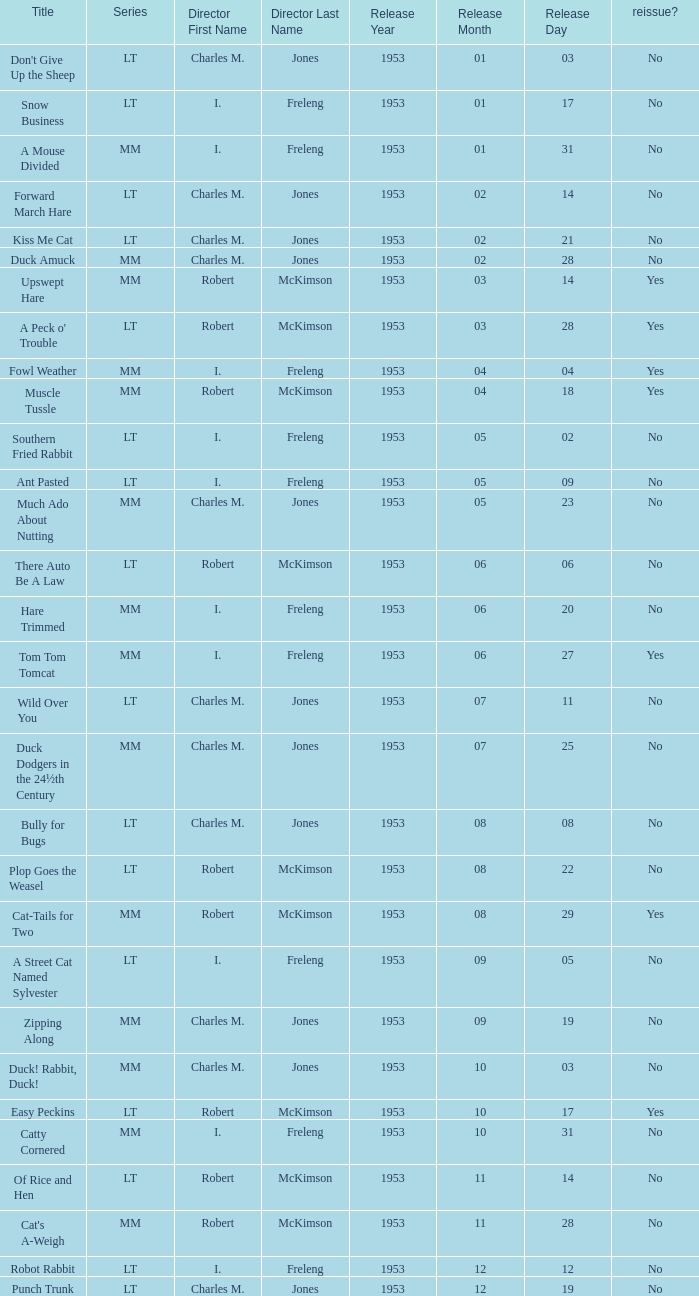What's the release date of Upswept Hare? 1953-03-14. 